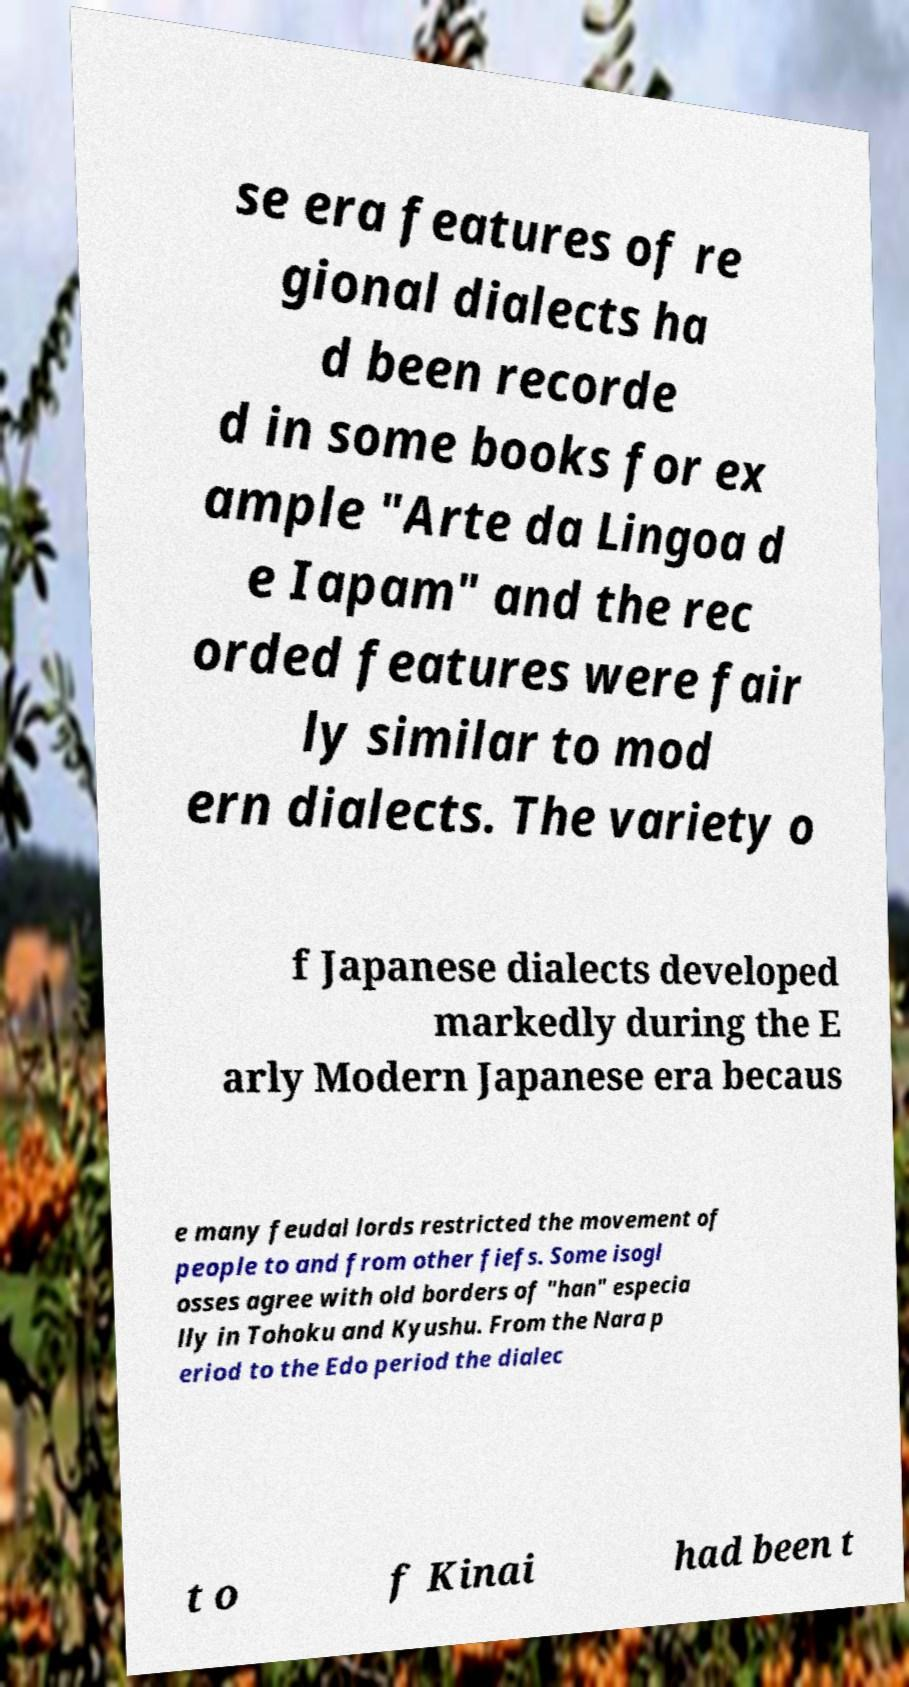Please read and relay the text visible in this image. What does it say? se era features of re gional dialects ha d been recorde d in some books for ex ample "Arte da Lingoa d e Iapam" and the rec orded features were fair ly similar to mod ern dialects. The variety o f Japanese dialects developed markedly during the E arly Modern Japanese era becaus e many feudal lords restricted the movement of people to and from other fiefs. Some isogl osses agree with old borders of "han" especia lly in Tohoku and Kyushu. From the Nara p eriod to the Edo period the dialec t o f Kinai had been t 